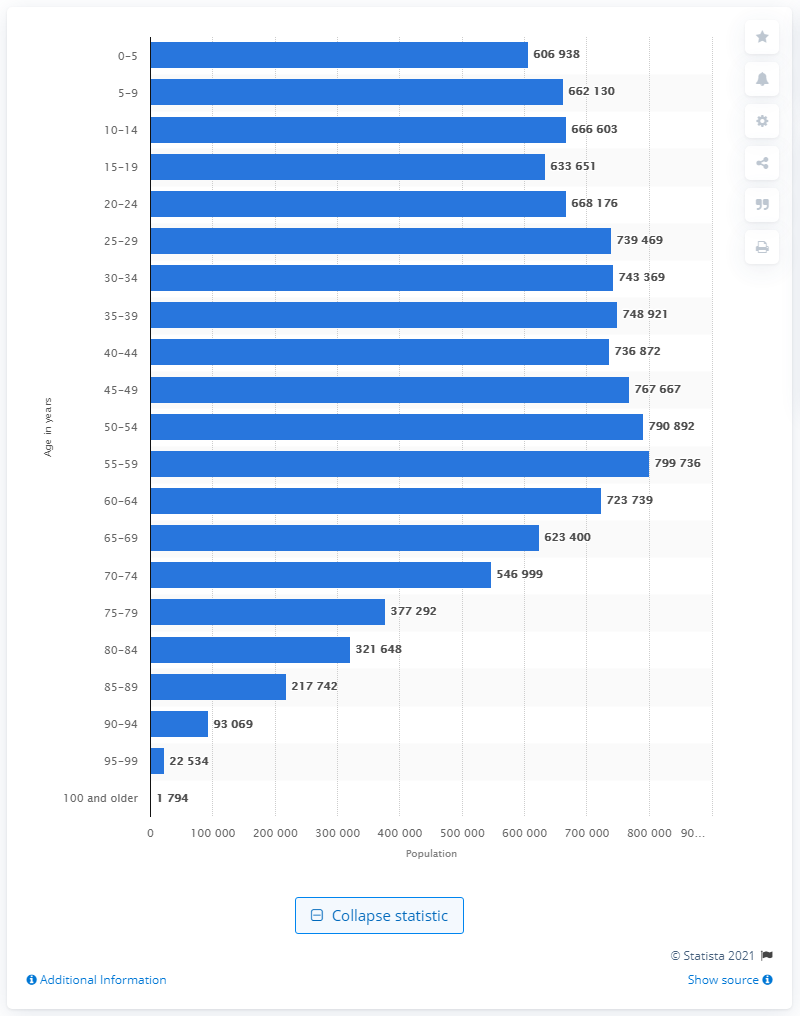Give some essential details in this illustration. In 2020, there were approximately 799,736 individuals between the ages of 55 and 59. 